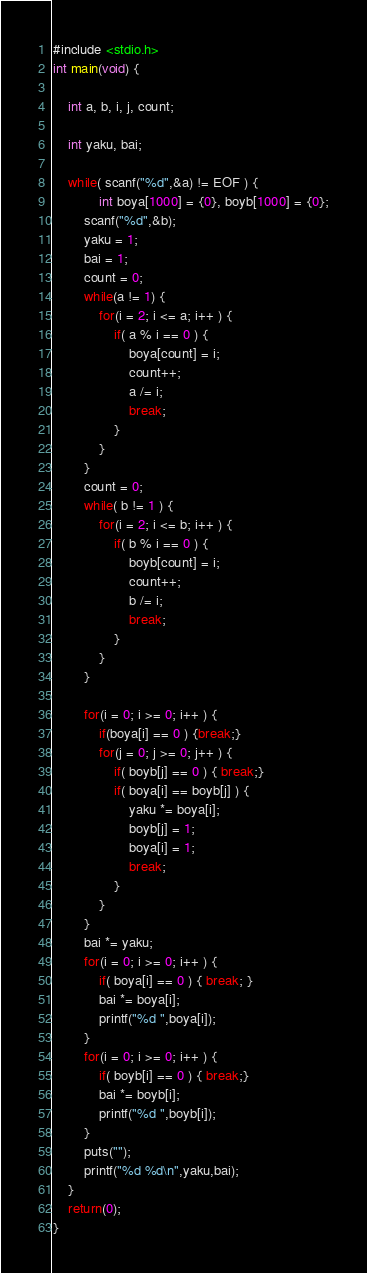Convert code to text. <code><loc_0><loc_0><loc_500><loc_500><_C_>#include <stdio.h>
int main(void) {
	
	int a, b, i, j, count;

	int yaku, bai;
	
	while( scanf("%d",&a) != EOF ) {
			int boya[1000] = {0}, boyb[1000] = {0};
		scanf("%d",&b);
		yaku = 1;
		bai = 1;
		count = 0;
		while(a != 1) {
			for(i = 2; i <= a; i++ ) {
				if( a % i == 0 ) {
					boya[count] = i;
					count++;
					a /= i;
					break;
				}
			}
		}
		count = 0;
		while( b != 1 ) {
			for(i = 2; i <= b; i++ ) {
				if( b % i == 0 ) {
					boyb[count] = i;
					count++;
					b /= i;
					break;
				}
			}
		}
		
		for(i = 0; i >= 0; i++ ) {
			if(boya[i] == 0 ) {break;}
			for(j = 0; j >= 0; j++ ) {
				if( boyb[j] == 0 ) { break;}
				if( boya[i] == boyb[j] ) {
					yaku *= boya[i];
					boyb[j] = 1;
					boya[i] = 1;
					break;
				}
			}    
		}
		bai *= yaku;
		for(i = 0; i >= 0; i++ ) {
			if( boya[i] == 0 ) { break; }
			bai *= boya[i];
			printf("%d ",boya[i]);
		}
		for(i = 0; i >= 0; i++ ) {
			if( boyb[i] == 0 ) { break;}
			bai *= boyb[i];
			printf("%d ",boyb[i]);
		}
		puts("");
		printf("%d %d\n",yaku,bai);
	}
	return(0);
}</code> 